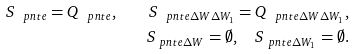<formula> <loc_0><loc_0><loc_500><loc_500>S _ { \ p n t { e } } = Q _ { \ p n t { e } } , \quad S _ { \ p n t { e } \Delta W \Delta W _ { 1 } } = Q _ { \ p n t { e } \Delta W \Delta W _ { 1 } } , \\ S _ { \ p n t { e } \Delta W } = \emptyset , \quad S _ { \ p n t { e } \Delta W _ { 1 } } = \emptyset .</formula> 